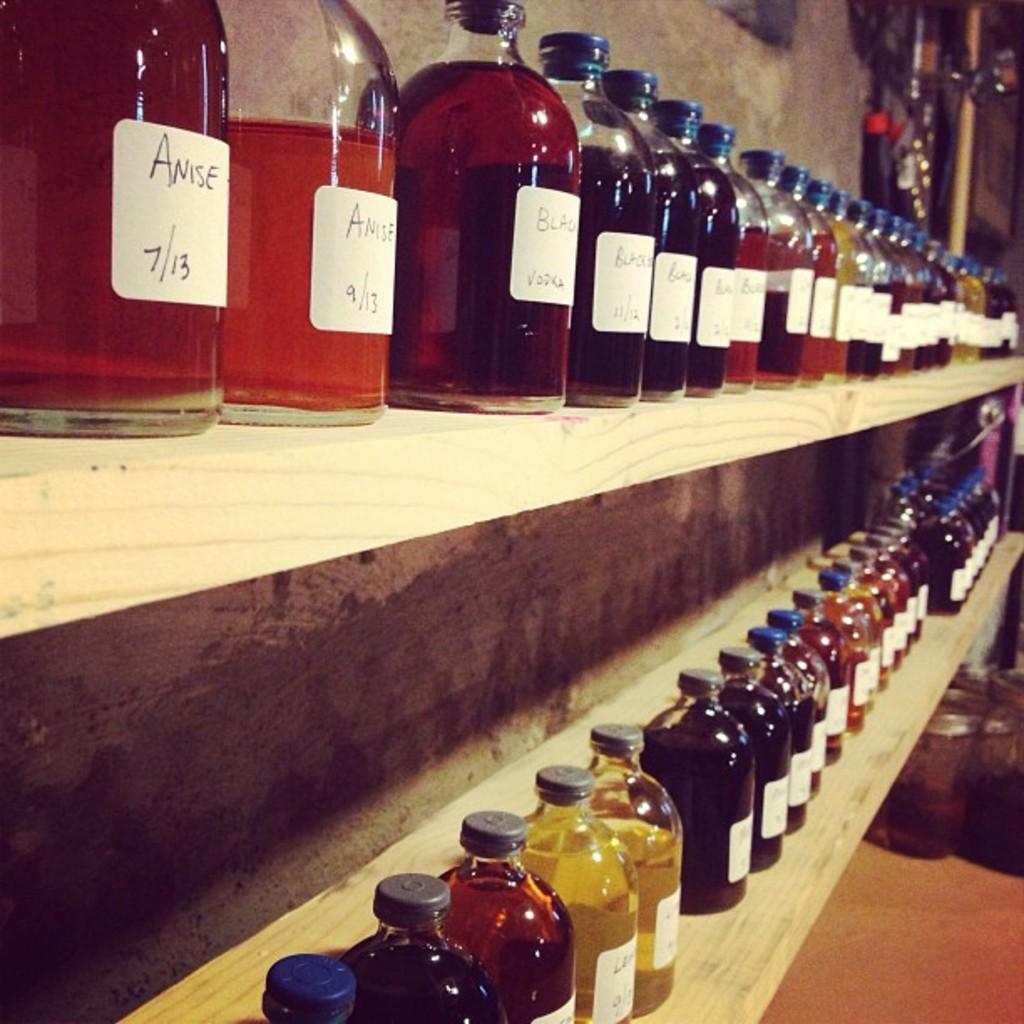Provide a one-sentence caption for the provided image. a few shelves full of tinctures such as Anise and others. 